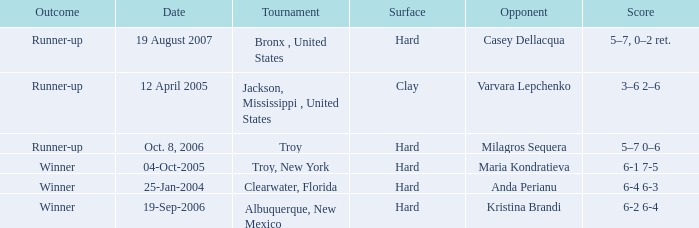Would you mind parsing the complete table? {'header': ['Outcome', 'Date', 'Tournament', 'Surface', 'Opponent', 'Score'], 'rows': [['Runner-up', '19 August 2007', 'Bronx , United States', 'Hard', 'Casey Dellacqua', '5–7, 0–2 ret.'], ['Runner-up', '12 April 2005', 'Jackson, Mississippi , United States', 'Clay', 'Varvara Lepchenko', '3–6 2–6'], ['Runner-up', 'Oct. 8, 2006', 'Troy', 'Hard', 'Milagros Sequera', '5–7 0–6'], ['Winner', '04-Oct-2005', 'Troy, New York', 'Hard', 'Maria Kondratieva', '6-1 7-5'], ['Winner', '25-Jan-2004', 'Clearwater, Florida', 'Hard', 'Anda Perianu', '6-4 6-3'], ['Winner', '19-Sep-2006', 'Albuquerque, New Mexico', 'Hard', 'Kristina Brandi', '6-2 6-4']]} What was the outcome of the game played on 19-Sep-2006? Winner. 